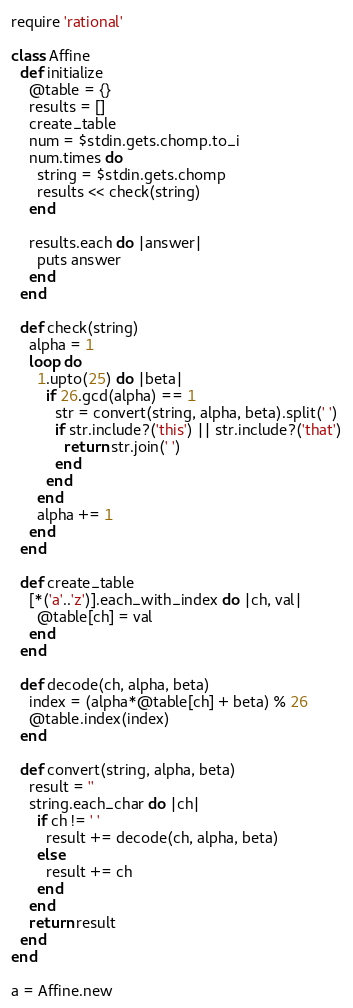<code> <loc_0><loc_0><loc_500><loc_500><_Ruby_>require 'rational'

class Affine
  def initialize
    @table = {}
    results = []
    create_table
    num = $stdin.gets.chomp.to_i
    num.times do 
      string = $stdin.gets.chomp
      results << check(string)
    end

    results.each do |answer|
      puts answer
    end
  end

  def check(string)
    alpha = 1
    loop do
      1.upto(25) do |beta|
        if 26.gcd(alpha) == 1
          str = convert(string, alpha, beta).split(' ')
          if str.include?('this') || str.include?('that')
            return str.join(' ') 
          end
        end
      end
      alpha += 1
    end
  end

  def create_table
    [*('a'..'z')].each_with_index do |ch, val|
      @table[ch] = val
    end
  end

  def decode(ch, alpha, beta)
    index = (alpha*@table[ch] + beta) % 26
    @table.index(index)
  end

  def convert(string, alpha, beta)
    result = ''
    string.each_char do |ch|
      if ch != ' '
        result += decode(ch, alpha, beta)
      else
        result += ch
      end
    end
    return result
  end
end

a = Affine.new</code> 